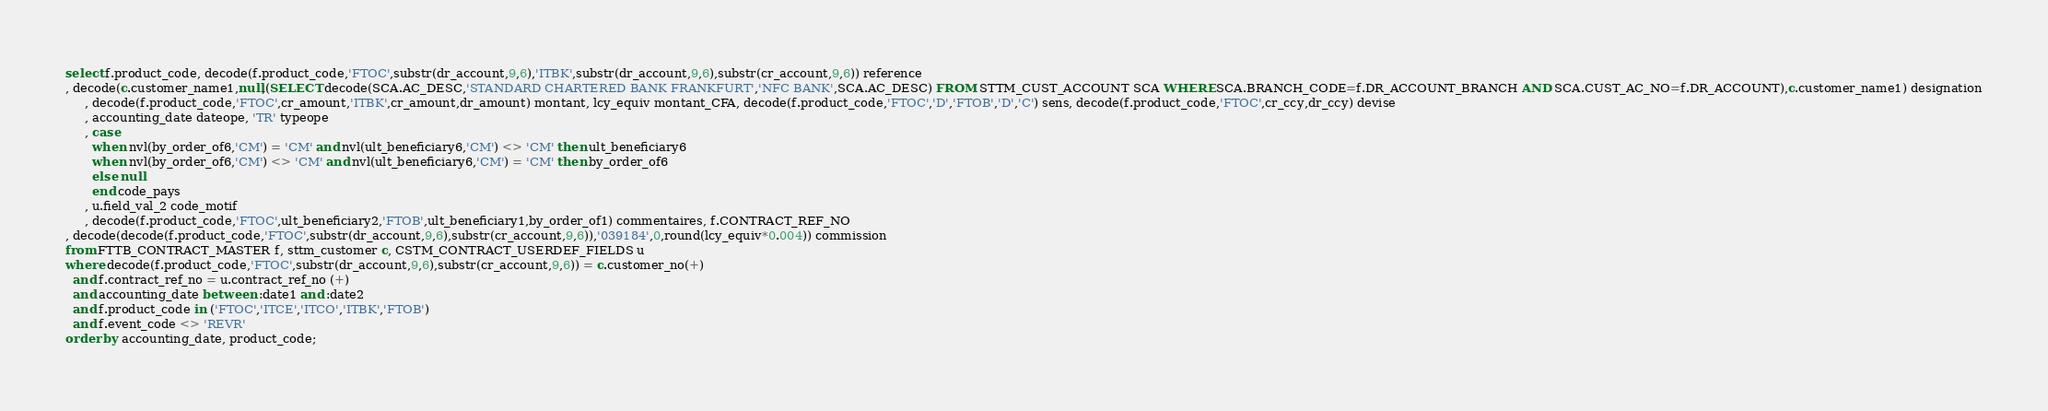Convert code to text. <code><loc_0><loc_0><loc_500><loc_500><_SQL_>select f.product_code, decode(f.product_code,'FTOC',substr(dr_account,9,6),'ITBK',substr(dr_account,9,6),substr(cr_account,9,6)) reference
, decode(c.customer_name1,null,(SELECT decode(SCA.AC_DESC,'STANDARD CHARTERED BANK FRANKFURT','NFC BANK',SCA.AC_DESC) FROM STTM_CUST_ACCOUNT SCA WHERE SCA.BRANCH_CODE=f.DR_ACCOUNT_BRANCH AND SCA.CUST_AC_NO=f.DR_ACCOUNT),c.customer_name1) designation
     , decode(f.product_code,'FTOC',cr_amount,'ITBK',cr_amount,dr_amount) montant, lcy_equiv montant_CFA, decode(f.product_code,'FTOC','D','FTOB','D','C') sens, decode(f.product_code,'FTOC',cr_ccy,dr_ccy) devise
     , accounting_date dateope, 'TR' typeope
     , case 
       when nvl(by_order_of6,'CM') = 'CM' and nvl(ult_beneficiary6,'CM') <> 'CM' then ult_beneficiary6
       when nvl(by_order_of6,'CM') <> 'CM' and nvl(ult_beneficiary6,'CM') = 'CM' then by_order_of6
       else null
       end code_pays
     , u.field_val_2 code_motif
     , decode(f.product_code,'FTOC',ult_beneficiary2,'FTOB',ult_beneficiary1,by_order_of1) commentaires, f.CONTRACT_REF_NO
, decode(decode(f.product_code,'FTOC',substr(dr_account,9,6),substr(cr_account,9,6)),'039184',0,round(lcy_equiv*0.004)) commission
from FTTB_CONTRACT_MASTER f, sttm_customer c, CSTM_CONTRACT_USERDEF_FIELDS u
where decode(f.product_code,'FTOC',substr(dr_account,9,6),substr(cr_account,9,6)) = c.customer_no(+)
  and f.contract_ref_no = u.contract_ref_no (+)
  and accounting_date between :date1 and :date2
  and f.product_code in ('FTOC','ITCE','ITCO','ITBK','FTOB')
  and f.event_code <> 'REVR'
order by accounting_date, product_code;
</code> 